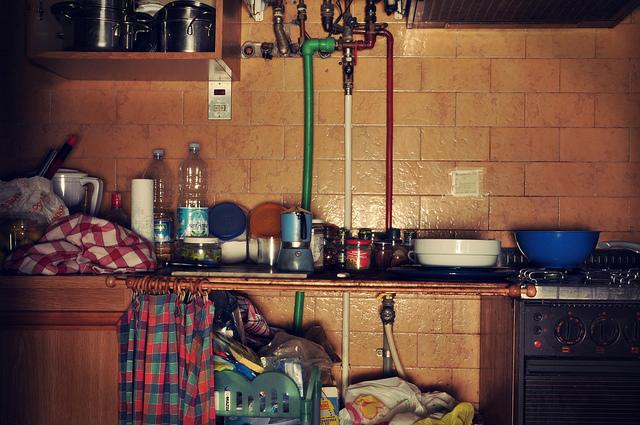When the pipes need to be worked on plumbers will be blocked from reaching it by what?

Choices:
A) sink
B) wall
C) counter
D) microwave counter 